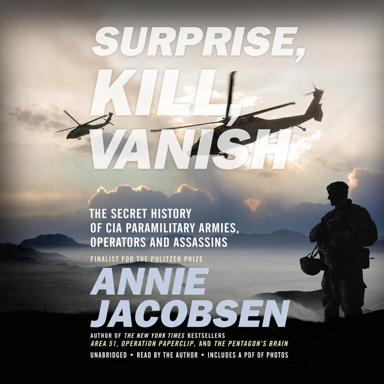What insights might the book offer about the CIA's impact on international relations? The book delves into the covert operations by the CIA, offering insights on how these secret missions have influenced global politics and international relations, often shaping historical events in ways that are not immediately visible to the public eye. How does the book analyze the ethical implications of such operations? Annie Jacobsen explores the moral complexities and ethical dilemmas faced by CIA operatives, questioning the justification of such covert actions in the broader context of national security and human rights. 